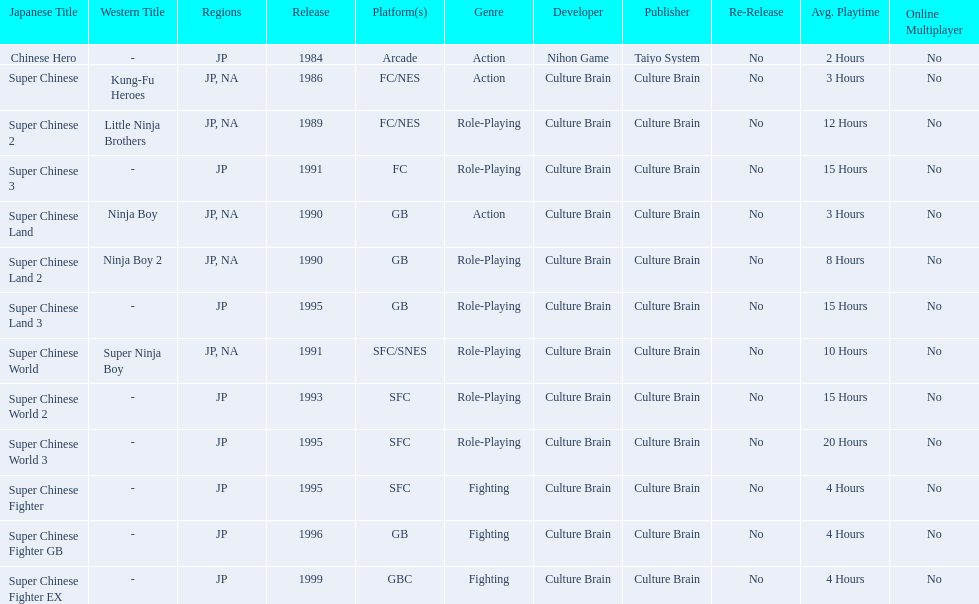Super ninja world was released in what countries? JP, NA. What was the original name for this title? Super Chinese World. 